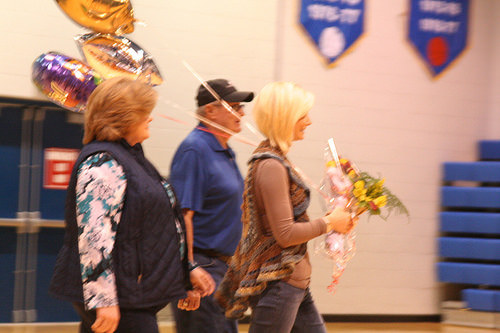<image>
Can you confirm if the balloon is on the flowers? Yes. Looking at the image, I can see the balloon is positioned on top of the flowers, with the flowers providing support. 